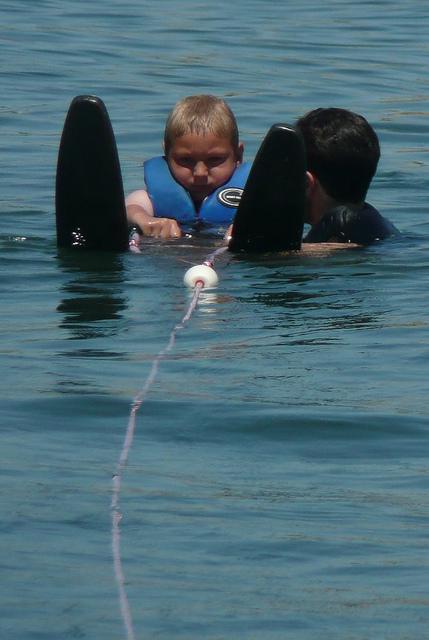Is the boy's hair wet?
Quick response, please. Yes. What color is the life vest?
Give a very brief answer. Blue. What object might have a fin?
Give a very brief answer. Fish. What is this child about to do?
Give a very brief answer. Water ski. Are they in the water?
Write a very short answer. Yes. 